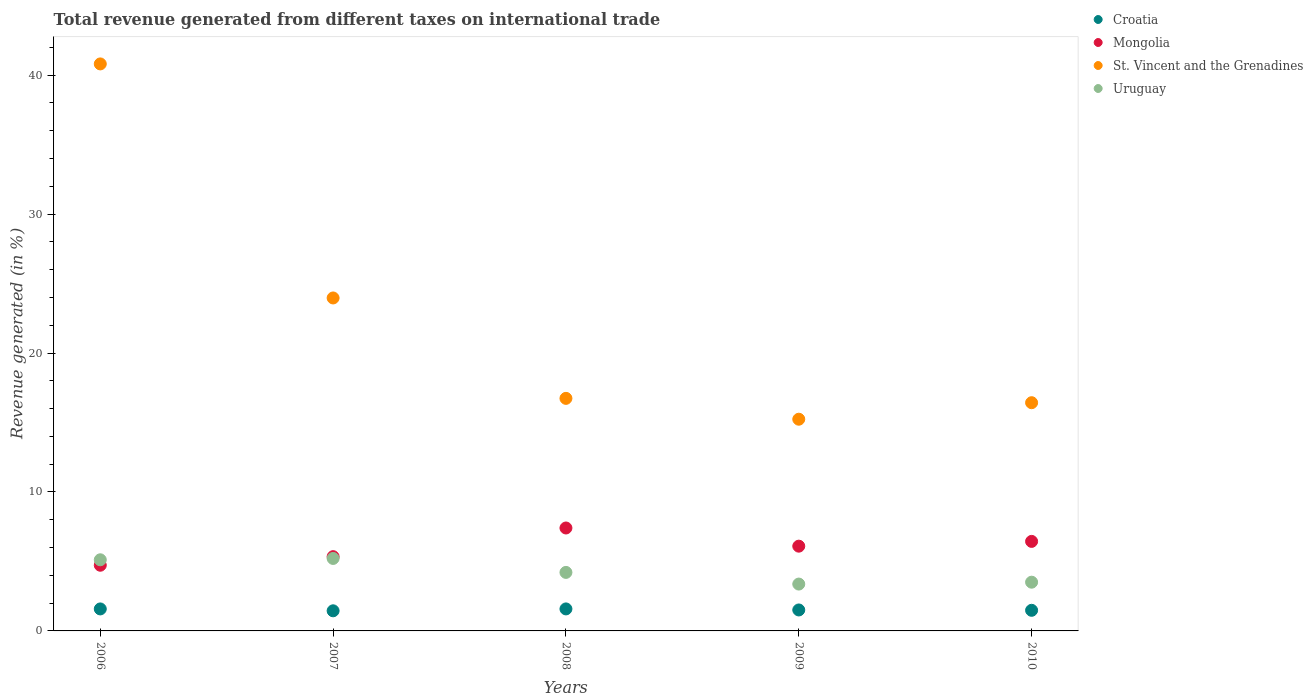How many different coloured dotlines are there?
Your answer should be compact. 4. What is the total revenue generated in Mongolia in 2006?
Provide a succinct answer. 4.73. Across all years, what is the maximum total revenue generated in St. Vincent and the Grenadines?
Offer a very short reply. 40.81. Across all years, what is the minimum total revenue generated in St. Vincent and the Grenadines?
Give a very brief answer. 15.24. In which year was the total revenue generated in Croatia maximum?
Provide a short and direct response. 2008. In which year was the total revenue generated in St. Vincent and the Grenadines minimum?
Provide a short and direct response. 2009. What is the total total revenue generated in St. Vincent and the Grenadines in the graph?
Make the answer very short. 113.18. What is the difference between the total revenue generated in St. Vincent and the Grenadines in 2009 and that in 2010?
Offer a terse response. -1.19. What is the difference between the total revenue generated in Croatia in 2010 and the total revenue generated in Uruguay in 2008?
Your response must be concise. -2.73. What is the average total revenue generated in Uruguay per year?
Your response must be concise. 4.29. In the year 2010, what is the difference between the total revenue generated in Mongolia and total revenue generated in Uruguay?
Make the answer very short. 2.94. What is the ratio of the total revenue generated in Croatia in 2007 to that in 2010?
Ensure brevity in your answer.  0.98. What is the difference between the highest and the second highest total revenue generated in St. Vincent and the Grenadines?
Ensure brevity in your answer.  16.85. What is the difference between the highest and the lowest total revenue generated in Uruguay?
Give a very brief answer. 1.84. In how many years, is the total revenue generated in St. Vincent and the Grenadines greater than the average total revenue generated in St. Vincent and the Grenadines taken over all years?
Keep it short and to the point. 2. How many dotlines are there?
Provide a succinct answer. 4. What is the difference between two consecutive major ticks on the Y-axis?
Offer a very short reply. 10. Are the values on the major ticks of Y-axis written in scientific E-notation?
Provide a short and direct response. No. What is the title of the graph?
Make the answer very short. Total revenue generated from different taxes on international trade. Does "Monaco" appear as one of the legend labels in the graph?
Offer a very short reply. No. What is the label or title of the X-axis?
Your answer should be compact. Years. What is the label or title of the Y-axis?
Give a very brief answer. Revenue generated (in %). What is the Revenue generated (in %) in Croatia in 2006?
Keep it short and to the point. 1.58. What is the Revenue generated (in %) in Mongolia in 2006?
Your response must be concise. 4.73. What is the Revenue generated (in %) of St. Vincent and the Grenadines in 2006?
Make the answer very short. 40.81. What is the Revenue generated (in %) in Uruguay in 2006?
Your response must be concise. 5.12. What is the Revenue generated (in %) in Croatia in 2007?
Offer a terse response. 1.45. What is the Revenue generated (in %) of Mongolia in 2007?
Your answer should be compact. 5.35. What is the Revenue generated (in %) in St. Vincent and the Grenadines in 2007?
Keep it short and to the point. 23.96. What is the Revenue generated (in %) of Uruguay in 2007?
Keep it short and to the point. 5.22. What is the Revenue generated (in %) of Croatia in 2008?
Your answer should be compact. 1.58. What is the Revenue generated (in %) in Mongolia in 2008?
Give a very brief answer. 7.41. What is the Revenue generated (in %) of St. Vincent and the Grenadines in 2008?
Provide a succinct answer. 16.74. What is the Revenue generated (in %) of Uruguay in 2008?
Your response must be concise. 4.21. What is the Revenue generated (in %) in Croatia in 2009?
Your response must be concise. 1.51. What is the Revenue generated (in %) in Mongolia in 2009?
Ensure brevity in your answer.  6.1. What is the Revenue generated (in %) of St. Vincent and the Grenadines in 2009?
Make the answer very short. 15.24. What is the Revenue generated (in %) of Uruguay in 2009?
Your response must be concise. 3.37. What is the Revenue generated (in %) in Croatia in 2010?
Give a very brief answer. 1.48. What is the Revenue generated (in %) in Mongolia in 2010?
Your answer should be compact. 6.44. What is the Revenue generated (in %) in St. Vincent and the Grenadines in 2010?
Provide a short and direct response. 16.43. What is the Revenue generated (in %) in Uruguay in 2010?
Provide a succinct answer. 3.51. Across all years, what is the maximum Revenue generated (in %) in Croatia?
Make the answer very short. 1.58. Across all years, what is the maximum Revenue generated (in %) of Mongolia?
Your response must be concise. 7.41. Across all years, what is the maximum Revenue generated (in %) of St. Vincent and the Grenadines?
Keep it short and to the point. 40.81. Across all years, what is the maximum Revenue generated (in %) of Uruguay?
Ensure brevity in your answer.  5.22. Across all years, what is the minimum Revenue generated (in %) of Croatia?
Provide a succinct answer. 1.45. Across all years, what is the minimum Revenue generated (in %) of Mongolia?
Your answer should be compact. 4.73. Across all years, what is the minimum Revenue generated (in %) in St. Vincent and the Grenadines?
Offer a terse response. 15.24. Across all years, what is the minimum Revenue generated (in %) of Uruguay?
Your answer should be compact. 3.37. What is the total Revenue generated (in %) in Croatia in the graph?
Give a very brief answer. 7.61. What is the total Revenue generated (in %) of Mongolia in the graph?
Keep it short and to the point. 30.03. What is the total Revenue generated (in %) of St. Vincent and the Grenadines in the graph?
Ensure brevity in your answer.  113.18. What is the total Revenue generated (in %) in Uruguay in the graph?
Make the answer very short. 21.43. What is the difference between the Revenue generated (in %) in Croatia in 2006 and that in 2007?
Provide a succinct answer. 0.13. What is the difference between the Revenue generated (in %) in Mongolia in 2006 and that in 2007?
Provide a succinct answer. -0.62. What is the difference between the Revenue generated (in %) in St. Vincent and the Grenadines in 2006 and that in 2007?
Keep it short and to the point. 16.85. What is the difference between the Revenue generated (in %) in Uruguay in 2006 and that in 2007?
Provide a succinct answer. -0.1. What is the difference between the Revenue generated (in %) of Croatia in 2006 and that in 2008?
Ensure brevity in your answer.  -0. What is the difference between the Revenue generated (in %) of Mongolia in 2006 and that in 2008?
Keep it short and to the point. -2.68. What is the difference between the Revenue generated (in %) of St. Vincent and the Grenadines in 2006 and that in 2008?
Your answer should be very brief. 24.07. What is the difference between the Revenue generated (in %) of Uruguay in 2006 and that in 2008?
Your answer should be very brief. 0.91. What is the difference between the Revenue generated (in %) in Croatia in 2006 and that in 2009?
Your answer should be very brief. 0.07. What is the difference between the Revenue generated (in %) of Mongolia in 2006 and that in 2009?
Provide a succinct answer. -1.37. What is the difference between the Revenue generated (in %) in St. Vincent and the Grenadines in 2006 and that in 2009?
Make the answer very short. 25.57. What is the difference between the Revenue generated (in %) of Uruguay in 2006 and that in 2009?
Offer a terse response. 1.75. What is the difference between the Revenue generated (in %) of Croatia in 2006 and that in 2010?
Keep it short and to the point. 0.1. What is the difference between the Revenue generated (in %) in Mongolia in 2006 and that in 2010?
Give a very brief answer. -1.72. What is the difference between the Revenue generated (in %) in St. Vincent and the Grenadines in 2006 and that in 2010?
Give a very brief answer. 24.38. What is the difference between the Revenue generated (in %) in Uruguay in 2006 and that in 2010?
Provide a short and direct response. 1.61. What is the difference between the Revenue generated (in %) of Croatia in 2007 and that in 2008?
Ensure brevity in your answer.  -0.14. What is the difference between the Revenue generated (in %) in Mongolia in 2007 and that in 2008?
Keep it short and to the point. -2.06. What is the difference between the Revenue generated (in %) in St. Vincent and the Grenadines in 2007 and that in 2008?
Provide a short and direct response. 7.23. What is the difference between the Revenue generated (in %) in Uruguay in 2007 and that in 2008?
Provide a short and direct response. 1. What is the difference between the Revenue generated (in %) of Croatia in 2007 and that in 2009?
Give a very brief answer. -0.06. What is the difference between the Revenue generated (in %) in Mongolia in 2007 and that in 2009?
Provide a short and direct response. -0.76. What is the difference between the Revenue generated (in %) in St. Vincent and the Grenadines in 2007 and that in 2009?
Your answer should be compact. 8.73. What is the difference between the Revenue generated (in %) in Uruguay in 2007 and that in 2009?
Offer a terse response. 1.84. What is the difference between the Revenue generated (in %) in Croatia in 2007 and that in 2010?
Ensure brevity in your answer.  -0.04. What is the difference between the Revenue generated (in %) in Mongolia in 2007 and that in 2010?
Your answer should be very brief. -1.1. What is the difference between the Revenue generated (in %) of St. Vincent and the Grenadines in 2007 and that in 2010?
Ensure brevity in your answer.  7.54. What is the difference between the Revenue generated (in %) of Uruguay in 2007 and that in 2010?
Your answer should be compact. 1.71. What is the difference between the Revenue generated (in %) of Croatia in 2008 and that in 2009?
Your response must be concise. 0.07. What is the difference between the Revenue generated (in %) in Mongolia in 2008 and that in 2009?
Give a very brief answer. 1.31. What is the difference between the Revenue generated (in %) in St. Vincent and the Grenadines in 2008 and that in 2009?
Give a very brief answer. 1.5. What is the difference between the Revenue generated (in %) in Uruguay in 2008 and that in 2009?
Your answer should be compact. 0.84. What is the difference between the Revenue generated (in %) in Croatia in 2008 and that in 2010?
Provide a succinct answer. 0.1. What is the difference between the Revenue generated (in %) of Mongolia in 2008 and that in 2010?
Provide a succinct answer. 0.96. What is the difference between the Revenue generated (in %) in St. Vincent and the Grenadines in 2008 and that in 2010?
Offer a very short reply. 0.31. What is the difference between the Revenue generated (in %) in Uruguay in 2008 and that in 2010?
Your response must be concise. 0.7. What is the difference between the Revenue generated (in %) in Croatia in 2009 and that in 2010?
Make the answer very short. 0.02. What is the difference between the Revenue generated (in %) in Mongolia in 2009 and that in 2010?
Your answer should be compact. -0.34. What is the difference between the Revenue generated (in %) of St. Vincent and the Grenadines in 2009 and that in 2010?
Your answer should be very brief. -1.19. What is the difference between the Revenue generated (in %) of Uruguay in 2009 and that in 2010?
Provide a short and direct response. -0.14. What is the difference between the Revenue generated (in %) in Croatia in 2006 and the Revenue generated (in %) in Mongolia in 2007?
Give a very brief answer. -3.76. What is the difference between the Revenue generated (in %) of Croatia in 2006 and the Revenue generated (in %) of St. Vincent and the Grenadines in 2007?
Your answer should be very brief. -22.38. What is the difference between the Revenue generated (in %) of Croatia in 2006 and the Revenue generated (in %) of Uruguay in 2007?
Your response must be concise. -3.63. What is the difference between the Revenue generated (in %) in Mongolia in 2006 and the Revenue generated (in %) in St. Vincent and the Grenadines in 2007?
Provide a succinct answer. -19.24. What is the difference between the Revenue generated (in %) in Mongolia in 2006 and the Revenue generated (in %) in Uruguay in 2007?
Your answer should be very brief. -0.49. What is the difference between the Revenue generated (in %) of St. Vincent and the Grenadines in 2006 and the Revenue generated (in %) of Uruguay in 2007?
Offer a very short reply. 35.59. What is the difference between the Revenue generated (in %) of Croatia in 2006 and the Revenue generated (in %) of Mongolia in 2008?
Give a very brief answer. -5.83. What is the difference between the Revenue generated (in %) of Croatia in 2006 and the Revenue generated (in %) of St. Vincent and the Grenadines in 2008?
Provide a succinct answer. -15.16. What is the difference between the Revenue generated (in %) of Croatia in 2006 and the Revenue generated (in %) of Uruguay in 2008?
Your response must be concise. -2.63. What is the difference between the Revenue generated (in %) of Mongolia in 2006 and the Revenue generated (in %) of St. Vincent and the Grenadines in 2008?
Your answer should be compact. -12.01. What is the difference between the Revenue generated (in %) in Mongolia in 2006 and the Revenue generated (in %) in Uruguay in 2008?
Ensure brevity in your answer.  0.52. What is the difference between the Revenue generated (in %) of St. Vincent and the Grenadines in 2006 and the Revenue generated (in %) of Uruguay in 2008?
Provide a short and direct response. 36.6. What is the difference between the Revenue generated (in %) in Croatia in 2006 and the Revenue generated (in %) in Mongolia in 2009?
Give a very brief answer. -4.52. What is the difference between the Revenue generated (in %) in Croatia in 2006 and the Revenue generated (in %) in St. Vincent and the Grenadines in 2009?
Offer a very short reply. -13.65. What is the difference between the Revenue generated (in %) in Croatia in 2006 and the Revenue generated (in %) in Uruguay in 2009?
Offer a very short reply. -1.79. What is the difference between the Revenue generated (in %) in Mongolia in 2006 and the Revenue generated (in %) in St. Vincent and the Grenadines in 2009?
Ensure brevity in your answer.  -10.51. What is the difference between the Revenue generated (in %) of Mongolia in 2006 and the Revenue generated (in %) of Uruguay in 2009?
Ensure brevity in your answer.  1.36. What is the difference between the Revenue generated (in %) of St. Vincent and the Grenadines in 2006 and the Revenue generated (in %) of Uruguay in 2009?
Offer a very short reply. 37.44. What is the difference between the Revenue generated (in %) in Croatia in 2006 and the Revenue generated (in %) in Mongolia in 2010?
Your response must be concise. -4.86. What is the difference between the Revenue generated (in %) of Croatia in 2006 and the Revenue generated (in %) of St. Vincent and the Grenadines in 2010?
Provide a short and direct response. -14.84. What is the difference between the Revenue generated (in %) of Croatia in 2006 and the Revenue generated (in %) of Uruguay in 2010?
Provide a short and direct response. -1.92. What is the difference between the Revenue generated (in %) in Mongolia in 2006 and the Revenue generated (in %) in St. Vincent and the Grenadines in 2010?
Give a very brief answer. -11.7. What is the difference between the Revenue generated (in %) in Mongolia in 2006 and the Revenue generated (in %) in Uruguay in 2010?
Offer a terse response. 1.22. What is the difference between the Revenue generated (in %) of St. Vincent and the Grenadines in 2006 and the Revenue generated (in %) of Uruguay in 2010?
Your answer should be very brief. 37.3. What is the difference between the Revenue generated (in %) in Croatia in 2007 and the Revenue generated (in %) in Mongolia in 2008?
Your answer should be very brief. -5.96. What is the difference between the Revenue generated (in %) of Croatia in 2007 and the Revenue generated (in %) of St. Vincent and the Grenadines in 2008?
Offer a terse response. -15.29. What is the difference between the Revenue generated (in %) of Croatia in 2007 and the Revenue generated (in %) of Uruguay in 2008?
Offer a very short reply. -2.76. What is the difference between the Revenue generated (in %) in Mongolia in 2007 and the Revenue generated (in %) in St. Vincent and the Grenadines in 2008?
Keep it short and to the point. -11.39. What is the difference between the Revenue generated (in %) in Mongolia in 2007 and the Revenue generated (in %) in Uruguay in 2008?
Provide a short and direct response. 1.13. What is the difference between the Revenue generated (in %) in St. Vincent and the Grenadines in 2007 and the Revenue generated (in %) in Uruguay in 2008?
Your answer should be compact. 19.75. What is the difference between the Revenue generated (in %) in Croatia in 2007 and the Revenue generated (in %) in Mongolia in 2009?
Make the answer very short. -4.65. What is the difference between the Revenue generated (in %) of Croatia in 2007 and the Revenue generated (in %) of St. Vincent and the Grenadines in 2009?
Keep it short and to the point. -13.79. What is the difference between the Revenue generated (in %) in Croatia in 2007 and the Revenue generated (in %) in Uruguay in 2009?
Make the answer very short. -1.92. What is the difference between the Revenue generated (in %) of Mongolia in 2007 and the Revenue generated (in %) of St. Vincent and the Grenadines in 2009?
Ensure brevity in your answer.  -9.89. What is the difference between the Revenue generated (in %) in Mongolia in 2007 and the Revenue generated (in %) in Uruguay in 2009?
Your response must be concise. 1.97. What is the difference between the Revenue generated (in %) in St. Vincent and the Grenadines in 2007 and the Revenue generated (in %) in Uruguay in 2009?
Keep it short and to the point. 20.59. What is the difference between the Revenue generated (in %) in Croatia in 2007 and the Revenue generated (in %) in Mongolia in 2010?
Your answer should be very brief. -5. What is the difference between the Revenue generated (in %) in Croatia in 2007 and the Revenue generated (in %) in St. Vincent and the Grenadines in 2010?
Offer a very short reply. -14.98. What is the difference between the Revenue generated (in %) in Croatia in 2007 and the Revenue generated (in %) in Uruguay in 2010?
Keep it short and to the point. -2.06. What is the difference between the Revenue generated (in %) in Mongolia in 2007 and the Revenue generated (in %) in St. Vincent and the Grenadines in 2010?
Provide a succinct answer. -11.08. What is the difference between the Revenue generated (in %) of Mongolia in 2007 and the Revenue generated (in %) of Uruguay in 2010?
Keep it short and to the point. 1.84. What is the difference between the Revenue generated (in %) in St. Vincent and the Grenadines in 2007 and the Revenue generated (in %) in Uruguay in 2010?
Provide a short and direct response. 20.46. What is the difference between the Revenue generated (in %) in Croatia in 2008 and the Revenue generated (in %) in Mongolia in 2009?
Provide a succinct answer. -4.52. What is the difference between the Revenue generated (in %) of Croatia in 2008 and the Revenue generated (in %) of St. Vincent and the Grenadines in 2009?
Offer a terse response. -13.65. What is the difference between the Revenue generated (in %) in Croatia in 2008 and the Revenue generated (in %) in Uruguay in 2009?
Ensure brevity in your answer.  -1.79. What is the difference between the Revenue generated (in %) in Mongolia in 2008 and the Revenue generated (in %) in St. Vincent and the Grenadines in 2009?
Offer a terse response. -7.83. What is the difference between the Revenue generated (in %) of Mongolia in 2008 and the Revenue generated (in %) of Uruguay in 2009?
Give a very brief answer. 4.04. What is the difference between the Revenue generated (in %) in St. Vincent and the Grenadines in 2008 and the Revenue generated (in %) in Uruguay in 2009?
Offer a very short reply. 13.37. What is the difference between the Revenue generated (in %) in Croatia in 2008 and the Revenue generated (in %) in Mongolia in 2010?
Your answer should be very brief. -4.86. What is the difference between the Revenue generated (in %) in Croatia in 2008 and the Revenue generated (in %) in St. Vincent and the Grenadines in 2010?
Your answer should be very brief. -14.84. What is the difference between the Revenue generated (in %) of Croatia in 2008 and the Revenue generated (in %) of Uruguay in 2010?
Your answer should be compact. -1.92. What is the difference between the Revenue generated (in %) in Mongolia in 2008 and the Revenue generated (in %) in St. Vincent and the Grenadines in 2010?
Give a very brief answer. -9.02. What is the difference between the Revenue generated (in %) in Mongolia in 2008 and the Revenue generated (in %) in Uruguay in 2010?
Ensure brevity in your answer.  3.9. What is the difference between the Revenue generated (in %) in St. Vincent and the Grenadines in 2008 and the Revenue generated (in %) in Uruguay in 2010?
Make the answer very short. 13.23. What is the difference between the Revenue generated (in %) in Croatia in 2009 and the Revenue generated (in %) in Mongolia in 2010?
Your answer should be compact. -4.94. What is the difference between the Revenue generated (in %) of Croatia in 2009 and the Revenue generated (in %) of St. Vincent and the Grenadines in 2010?
Provide a short and direct response. -14.92. What is the difference between the Revenue generated (in %) of Croatia in 2009 and the Revenue generated (in %) of Uruguay in 2010?
Provide a succinct answer. -2. What is the difference between the Revenue generated (in %) of Mongolia in 2009 and the Revenue generated (in %) of St. Vincent and the Grenadines in 2010?
Give a very brief answer. -10.33. What is the difference between the Revenue generated (in %) of Mongolia in 2009 and the Revenue generated (in %) of Uruguay in 2010?
Make the answer very short. 2.59. What is the difference between the Revenue generated (in %) in St. Vincent and the Grenadines in 2009 and the Revenue generated (in %) in Uruguay in 2010?
Make the answer very short. 11.73. What is the average Revenue generated (in %) in Croatia per year?
Offer a terse response. 1.52. What is the average Revenue generated (in %) of Mongolia per year?
Ensure brevity in your answer.  6.01. What is the average Revenue generated (in %) in St. Vincent and the Grenadines per year?
Give a very brief answer. 22.64. What is the average Revenue generated (in %) of Uruguay per year?
Offer a terse response. 4.29. In the year 2006, what is the difference between the Revenue generated (in %) of Croatia and Revenue generated (in %) of Mongolia?
Provide a succinct answer. -3.14. In the year 2006, what is the difference between the Revenue generated (in %) of Croatia and Revenue generated (in %) of St. Vincent and the Grenadines?
Give a very brief answer. -39.23. In the year 2006, what is the difference between the Revenue generated (in %) in Croatia and Revenue generated (in %) in Uruguay?
Offer a terse response. -3.54. In the year 2006, what is the difference between the Revenue generated (in %) of Mongolia and Revenue generated (in %) of St. Vincent and the Grenadines?
Your answer should be compact. -36.08. In the year 2006, what is the difference between the Revenue generated (in %) in Mongolia and Revenue generated (in %) in Uruguay?
Provide a succinct answer. -0.39. In the year 2006, what is the difference between the Revenue generated (in %) of St. Vincent and the Grenadines and Revenue generated (in %) of Uruguay?
Provide a succinct answer. 35.69. In the year 2007, what is the difference between the Revenue generated (in %) in Croatia and Revenue generated (in %) in Mongolia?
Ensure brevity in your answer.  -3.9. In the year 2007, what is the difference between the Revenue generated (in %) of Croatia and Revenue generated (in %) of St. Vincent and the Grenadines?
Keep it short and to the point. -22.52. In the year 2007, what is the difference between the Revenue generated (in %) of Croatia and Revenue generated (in %) of Uruguay?
Offer a terse response. -3.77. In the year 2007, what is the difference between the Revenue generated (in %) of Mongolia and Revenue generated (in %) of St. Vincent and the Grenadines?
Keep it short and to the point. -18.62. In the year 2007, what is the difference between the Revenue generated (in %) in Mongolia and Revenue generated (in %) in Uruguay?
Keep it short and to the point. 0.13. In the year 2007, what is the difference between the Revenue generated (in %) of St. Vincent and the Grenadines and Revenue generated (in %) of Uruguay?
Offer a terse response. 18.75. In the year 2008, what is the difference between the Revenue generated (in %) of Croatia and Revenue generated (in %) of Mongolia?
Your response must be concise. -5.82. In the year 2008, what is the difference between the Revenue generated (in %) of Croatia and Revenue generated (in %) of St. Vincent and the Grenadines?
Your answer should be very brief. -15.15. In the year 2008, what is the difference between the Revenue generated (in %) in Croatia and Revenue generated (in %) in Uruguay?
Offer a terse response. -2.63. In the year 2008, what is the difference between the Revenue generated (in %) of Mongolia and Revenue generated (in %) of St. Vincent and the Grenadines?
Make the answer very short. -9.33. In the year 2008, what is the difference between the Revenue generated (in %) of Mongolia and Revenue generated (in %) of Uruguay?
Keep it short and to the point. 3.2. In the year 2008, what is the difference between the Revenue generated (in %) of St. Vincent and the Grenadines and Revenue generated (in %) of Uruguay?
Your response must be concise. 12.53. In the year 2009, what is the difference between the Revenue generated (in %) in Croatia and Revenue generated (in %) in Mongolia?
Provide a short and direct response. -4.59. In the year 2009, what is the difference between the Revenue generated (in %) in Croatia and Revenue generated (in %) in St. Vincent and the Grenadines?
Your answer should be compact. -13.73. In the year 2009, what is the difference between the Revenue generated (in %) of Croatia and Revenue generated (in %) of Uruguay?
Your response must be concise. -1.86. In the year 2009, what is the difference between the Revenue generated (in %) of Mongolia and Revenue generated (in %) of St. Vincent and the Grenadines?
Make the answer very short. -9.14. In the year 2009, what is the difference between the Revenue generated (in %) of Mongolia and Revenue generated (in %) of Uruguay?
Your answer should be compact. 2.73. In the year 2009, what is the difference between the Revenue generated (in %) of St. Vincent and the Grenadines and Revenue generated (in %) of Uruguay?
Your answer should be very brief. 11.87. In the year 2010, what is the difference between the Revenue generated (in %) of Croatia and Revenue generated (in %) of Mongolia?
Provide a short and direct response. -4.96. In the year 2010, what is the difference between the Revenue generated (in %) of Croatia and Revenue generated (in %) of St. Vincent and the Grenadines?
Offer a very short reply. -14.94. In the year 2010, what is the difference between the Revenue generated (in %) in Croatia and Revenue generated (in %) in Uruguay?
Give a very brief answer. -2.02. In the year 2010, what is the difference between the Revenue generated (in %) in Mongolia and Revenue generated (in %) in St. Vincent and the Grenadines?
Keep it short and to the point. -9.98. In the year 2010, what is the difference between the Revenue generated (in %) in Mongolia and Revenue generated (in %) in Uruguay?
Provide a succinct answer. 2.94. In the year 2010, what is the difference between the Revenue generated (in %) of St. Vincent and the Grenadines and Revenue generated (in %) of Uruguay?
Your answer should be very brief. 12.92. What is the ratio of the Revenue generated (in %) of Croatia in 2006 to that in 2007?
Offer a terse response. 1.09. What is the ratio of the Revenue generated (in %) of Mongolia in 2006 to that in 2007?
Your response must be concise. 0.88. What is the ratio of the Revenue generated (in %) of St. Vincent and the Grenadines in 2006 to that in 2007?
Provide a succinct answer. 1.7. What is the ratio of the Revenue generated (in %) in Uruguay in 2006 to that in 2007?
Your answer should be very brief. 0.98. What is the ratio of the Revenue generated (in %) in Mongolia in 2006 to that in 2008?
Ensure brevity in your answer.  0.64. What is the ratio of the Revenue generated (in %) of St. Vincent and the Grenadines in 2006 to that in 2008?
Give a very brief answer. 2.44. What is the ratio of the Revenue generated (in %) in Uruguay in 2006 to that in 2008?
Provide a short and direct response. 1.22. What is the ratio of the Revenue generated (in %) in Croatia in 2006 to that in 2009?
Ensure brevity in your answer.  1.05. What is the ratio of the Revenue generated (in %) of Mongolia in 2006 to that in 2009?
Offer a very short reply. 0.78. What is the ratio of the Revenue generated (in %) in St. Vincent and the Grenadines in 2006 to that in 2009?
Provide a succinct answer. 2.68. What is the ratio of the Revenue generated (in %) in Uruguay in 2006 to that in 2009?
Make the answer very short. 1.52. What is the ratio of the Revenue generated (in %) in Croatia in 2006 to that in 2010?
Offer a very short reply. 1.07. What is the ratio of the Revenue generated (in %) of Mongolia in 2006 to that in 2010?
Make the answer very short. 0.73. What is the ratio of the Revenue generated (in %) of St. Vincent and the Grenadines in 2006 to that in 2010?
Provide a succinct answer. 2.48. What is the ratio of the Revenue generated (in %) of Uruguay in 2006 to that in 2010?
Give a very brief answer. 1.46. What is the ratio of the Revenue generated (in %) in Croatia in 2007 to that in 2008?
Offer a very short reply. 0.91. What is the ratio of the Revenue generated (in %) of Mongolia in 2007 to that in 2008?
Provide a succinct answer. 0.72. What is the ratio of the Revenue generated (in %) in St. Vincent and the Grenadines in 2007 to that in 2008?
Provide a succinct answer. 1.43. What is the ratio of the Revenue generated (in %) of Uruguay in 2007 to that in 2008?
Offer a terse response. 1.24. What is the ratio of the Revenue generated (in %) in Croatia in 2007 to that in 2009?
Your response must be concise. 0.96. What is the ratio of the Revenue generated (in %) in Mongolia in 2007 to that in 2009?
Make the answer very short. 0.88. What is the ratio of the Revenue generated (in %) in St. Vincent and the Grenadines in 2007 to that in 2009?
Ensure brevity in your answer.  1.57. What is the ratio of the Revenue generated (in %) in Uruguay in 2007 to that in 2009?
Offer a terse response. 1.55. What is the ratio of the Revenue generated (in %) of Croatia in 2007 to that in 2010?
Make the answer very short. 0.98. What is the ratio of the Revenue generated (in %) in Mongolia in 2007 to that in 2010?
Offer a terse response. 0.83. What is the ratio of the Revenue generated (in %) in St. Vincent and the Grenadines in 2007 to that in 2010?
Provide a succinct answer. 1.46. What is the ratio of the Revenue generated (in %) in Uruguay in 2007 to that in 2010?
Offer a terse response. 1.49. What is the ratio of the Revenue generated (in %) in Croatia in 2008 to that in 2009?
Ensure brevity in your answer.  1.05. What is the ratio of the Revenue generated (in %) in Mongolia in 2008 to that in 2009?
Your answer should be compact. 1.21. What is the ratio of the Revenue generated (in %) in St. Vincent and the Grenadines in 2008 to that in 2009?
Make the answer very short. 1.1. What is the ratio of the Revenue generated (in %) of Uruguay in 2008 to that in 2009?
Give a very brief answer. 1.25. What is the ratio of the Revenue generated (in %) in Croatia in 2008 to that in 2010?
Give a very brief answer. 1.07. What is the ratio of the Revenue generated (in %) in Mongolia in 2008 to that in 2010?
Your answer should be compact. 1.15. What is the ratio of the Revenue generated (in %) of St. Vincent and the Grenadines in 2008 to that in 2010?
Your answer should be very brief. 1.02. What is the ratio of the Revenue generated (in %) in Uruguay in 2008 to that in 2010?
Provide a succinct answer. 1.2. What is the ratio of the Revenue generated (in %) in Croatia in 2009 to that in 2010?
Offer a terse response. 1.02. What is the ratio of the Revenue generated (in %) of Mongolia in 2009 to that in 2010?
Offer a very short reply. 0.95. What is the ratio of the Revenue generated (in %) of St. Vincent and the Grenadines in 2009 to that in 2010?
Provide a succinct answer. 0.93. What is the ratio of the Revenue generated (in %) in Uruguay in 2009 to that in 2010?
Make the answer very short. 0.96. What is the difference between the highest and the second highest Revenue generated (in %) in Croatia?
Your answer should be compact. 0. What is the difference between the highest and the second highest Revenue generated (in %) in Mongolia?
Provide a short and direct response. 0.96. What is the difference between the highest and the second highest Revenue generated (in %) of St. Vincent and the Grenadines?
Keep it short and to the point. 16.85. What is the difference between the highest and the second highest Revenue generated (in %) in Uruguay?
Your answer should be very brief. 0.1. What is the difference between the highest and the lowest Revenue generated (in %) of Croatia?
Your answer should be compact. 0.14. What is the difference between the highest and the lowest Revenue generated (in %) in Mongolia?
Offer a very short reply. 2.68. What is the difference between the highest and the lowest Revenue generated (in %) in St. Vincent and the Grenadines?
Keep it short and to the point. 25.57. What is the difference between the highest and the lowest Revenue generated (in %) in Uruguay?
Your answer should be compact. 1.84. 